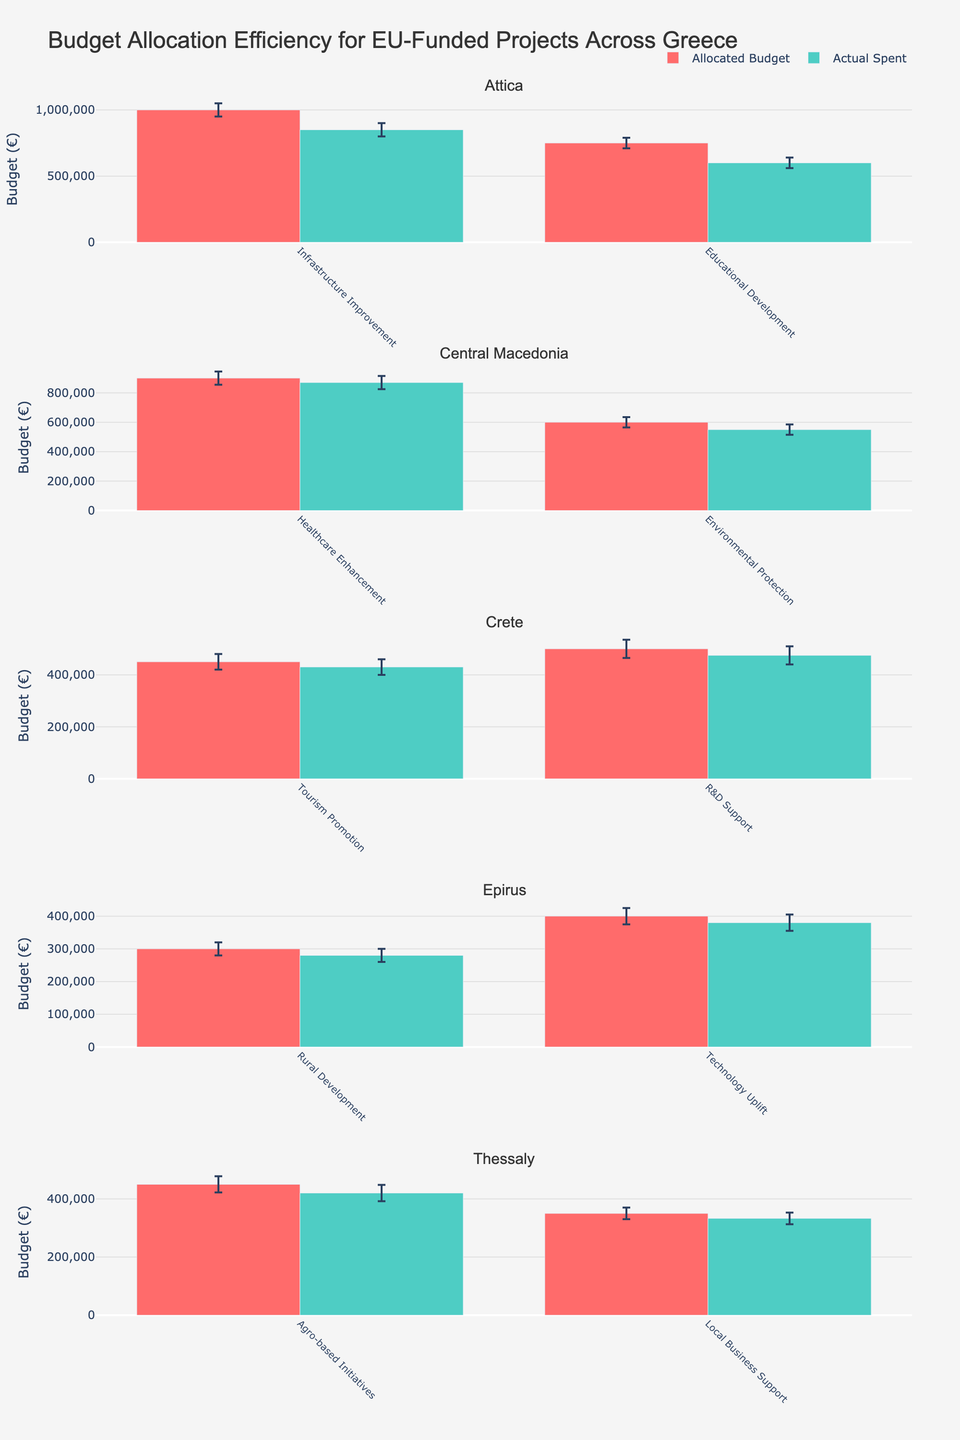What is the title of the figure? The title is located at the top of the figure. It is usually in larger font than the other text in the plot to make it easily noticeable.
Answer: Budget Allocation Efficiency for EU-Funded Projects Across Greece Which region has the highest Allocated Budget for a single project, and what is the project? Look at the bar heights in the Allocated Budget series across all regions. Identify the highest bar and its corresponding project and region.
Answer: Attica, Infrastructure Improvement What is the actual spent amount for the Educational Development project in Attica? Find the bar corresponding to the Educational Development project in the Attica subplot. The height of this bar represents the Actual Spent amount.
Answer: 600,000 EUR Compare the Allocated Budget and Actual Spent for the R&D Support project in Crete. How much less was actually spent? Identify the Allocated Budget and Actual Spent bars for the R&D Support project in Crete. Subtract the Actual Spent amount from the Allocated Budget.
Answer: 25,000 EUR less What are the confidence intervals (error bars) for the Environmental Protection project in Central Macedonia? The error bars are shown as vertical lines extending from the bar tops. Identify these for the Environmental Protection project in Central Macedonia.
Answer: ±35,000 EUR Which region shows the most significant discrepancy between Allocated Budget and Actual Spent on any project? Look for the projects in each region where the difference between Allocated Budget and Actual Spent is the largest. This can be done by evaluating the visual gaps between the two corresponding bars.
Answer: Attica For the Rural Development project in Epirus, if the Allocated Budget is increased by 10%, how would this compare to the Actual Spent? Calculate 10% of the Allocated Budget for the Rural Development project in Epirus and add this to the original budget. Compare the resulting figure to the Actual Spent.
Answer: 330,000 EUR (50,000 EUR more than Actual Spent) Which project in Thessaly has a higher Actual Spent compared to the Allocated Budget? Check the individual bars for projects in Thessaly. Identify any where the Actual Spent bar is higher than the Allocated Budget bar (if any exist).
Answer: None What is the average Allocated Budget for projects in Crete? Sum the Allocated Budget for all projects in Crete and divide by the number of projects in Crete.
Answer: 475,000 EUR Compare the budget allocation efficiency (difference between Allocated Budget and Actual Spent) between regions. Which region appears most efficient? For each region, calculate the difference between Allocated Budget and Actual Spent for all projects and compare those differences. The region with the smallest average difference is the most efficient.
Answer: Central Macedonia 